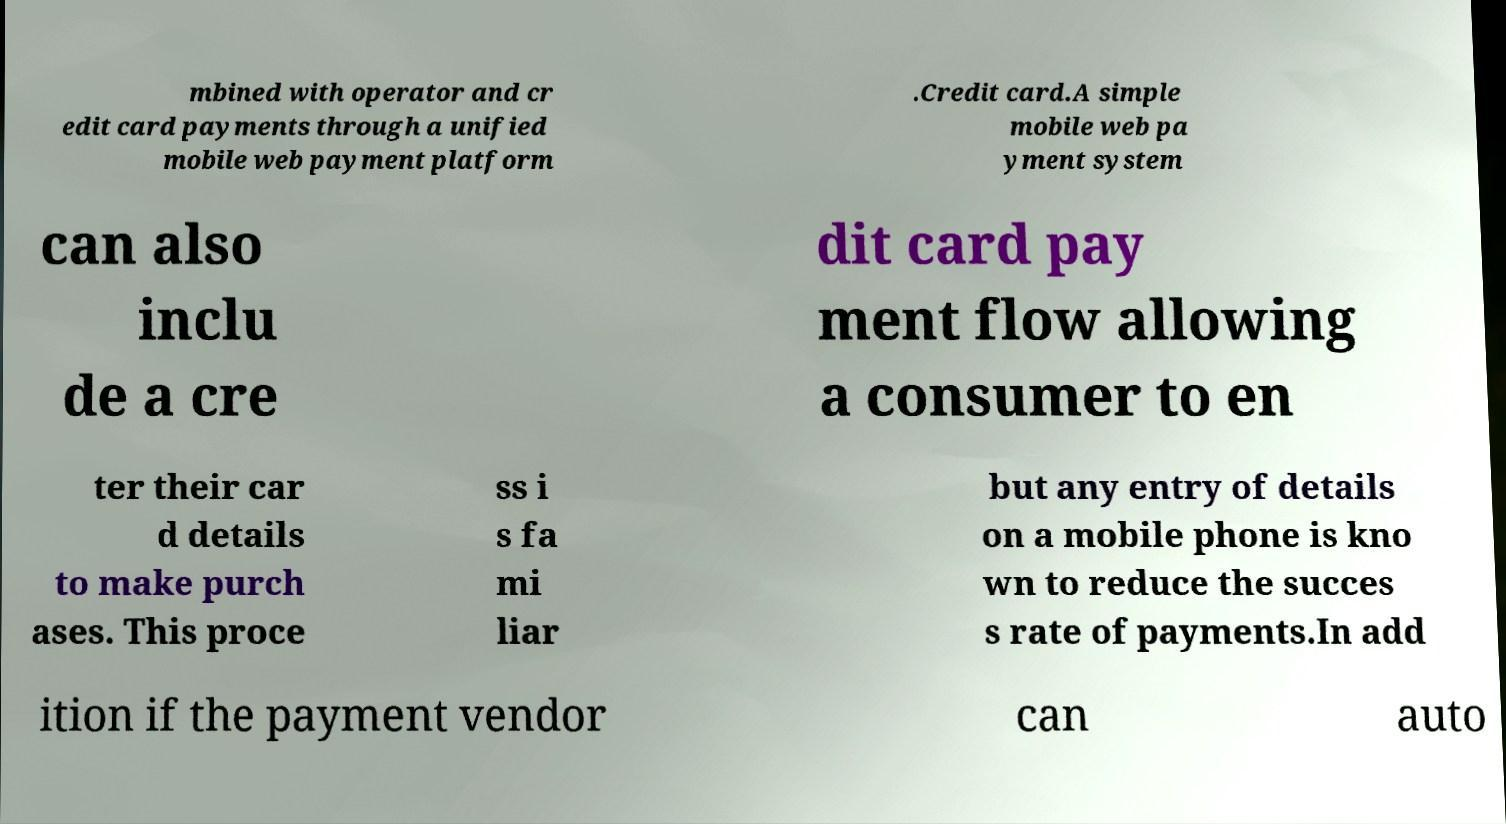Please read and relay the text visible in this image. What does it say? mbined with operator and cr edit card payments through a unified mobile web payment platform .Credit card.A simple mobile web pa yment system can also inclu de a cre dit card pay ment flow allowing a consumer to en ter their car d details to make purch ases. This proce ss i s fa mi liar but any entry of details on a mobile phone is kno wn to reduce the succes s rate of payments.In add ition if the payment vendor can auto 